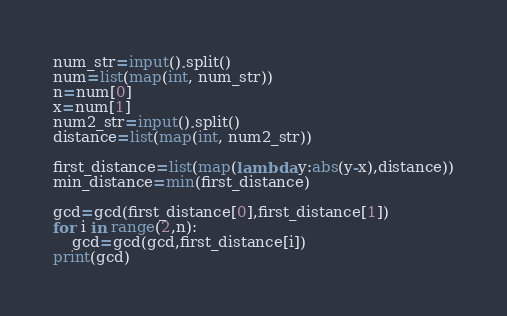<code> <loc_0><loc_0><loc_500><loc_500><_Python_>num_str=input().split()
num=list(map(int, num_str))
n=num[0]
x=num[1]
num2_str=input().split()
distance=list(map(int, num2_str))

first_distance=list(map(lambda y:abs(y-x),distance))
min_distance=min(first_distance)

gcd=gcd(first_distance[0],first_distance[1])
for i in range(2,n):
    gcd=gcd(gcd,first_distance[i])
print(gcd)</code> 